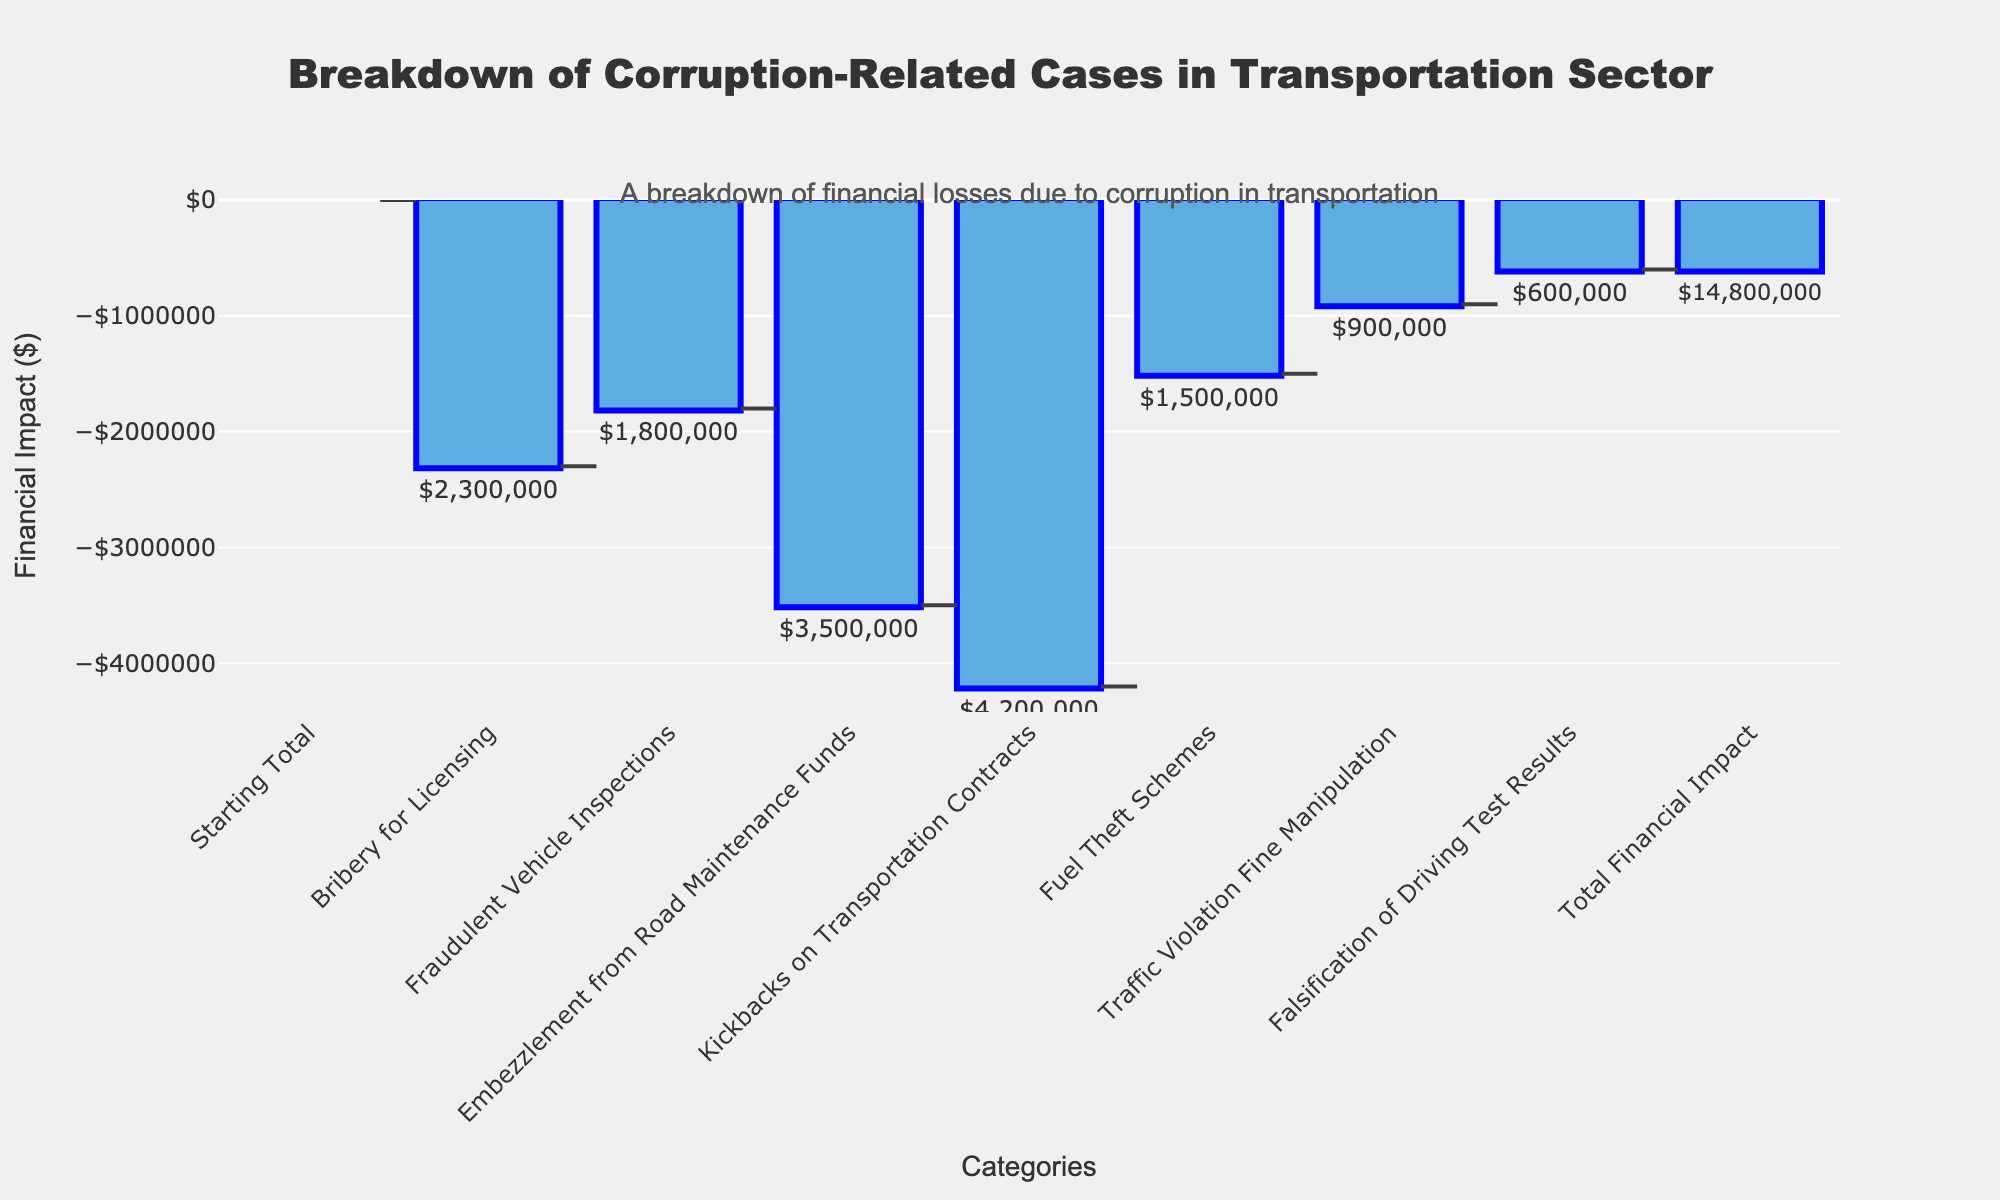What is the title of the figure? The title can be found at the top center of the figure. It reads "Breakdown of Corruption-Related Cases in the Transportation Sector."
Answer: Breakdown of Corruption-Related Cases in the Transportation Sector Which type of corruption case has the highest financial impact? By looking at the bars in the figure, the category with the largest downward bar represents the highest financial impact. "Kickbacks on Transportation Contracts" has the highest financial impact.
Answer: Kickbacks on Transportation Contracts What is the total financial impact of all corruption-related cases? The total financial impact is represented by the final bar in the waterfall chart, usually labeled at the end. It shows that the total financial impact is -$14,800,000.
Answer: $14,800,000 What is the financial impact of fraudulent vehicle inspections compared to fuel theft schemes? Comparing the heights of the bars for "Fraudulent Vehicle Inspections" and "Fuel Theft Schemes" shows the financial impact for each. Fraudulent Vehicle Inspections are -$1,800,000, and Fuel Theft Schemes are -$1,500,000.
Answer: Fraudelent Vehicle Inspections: $1,800,000; Fuel Theft Schemes: $1,500,000 How many different categories of corruption cases are shown in the figure? By counting the number of bars excluding the starting total and ending total in the figure, we can identify the number of corruption categories. There are 7 different categories shown.
Answer: 7 If embezzlement and kickbacks were eliminated, what would the new total financial impact be? Add the impact of "Embezzlement from Road Maintenance Funds" (-$3,500,000) and "Kickbacks on Transportation Contracts" (-$4,200,000) and then subtract this from the total financial impact (-$14,800,000). So, -$14,800,000 + $3,500,000 + $4,200,000 = -$7,100,000.
Answer: $7,100,000 What is the combined financial impact of bribery for licensing and traffic violation fine manipulation? Add the financial impact of "Bribery for Licensing" (-$2,300,000) and "Traffic Violation Fine Manipulation" (-$900,000). -$2,300,000 + -$900,000 = -$3,200,000.
Answer: $3,200,000 Which type of corruption case has the smallest financial impact? By looking at the bars and identifying the shortest one, the smallest financial impact is "Falsification of Driving Test Results" which is -$600,000.
Answer: Falsification of Driving Test Results How does the financial impact of fuel theft schemes compare to fraudulent vehicle inspections? Comparing the heights of the bars, "Fuel Theft Schemes" (-$1,500,000) is slightly less impactful than "Fraudulent Vehicle Inspections" (-$1,800,000).
Answer: Fuel Theft Schemes are $300,000 less impactful What is the average financial impact per corruption category? Sum all individual impacts and divide by the number of categories: (-$2,300,000) + (-$1,800,000) + (-$3,500,000) + (-$4,200,000) + (-$1,500,000) + (-$900,000) + (-$600,000) = -$14,800,000. Divide by 7 categories: -$14,800,000 / 7 ≈ -$2,114,286.
Answer: ≈$2,114,286 